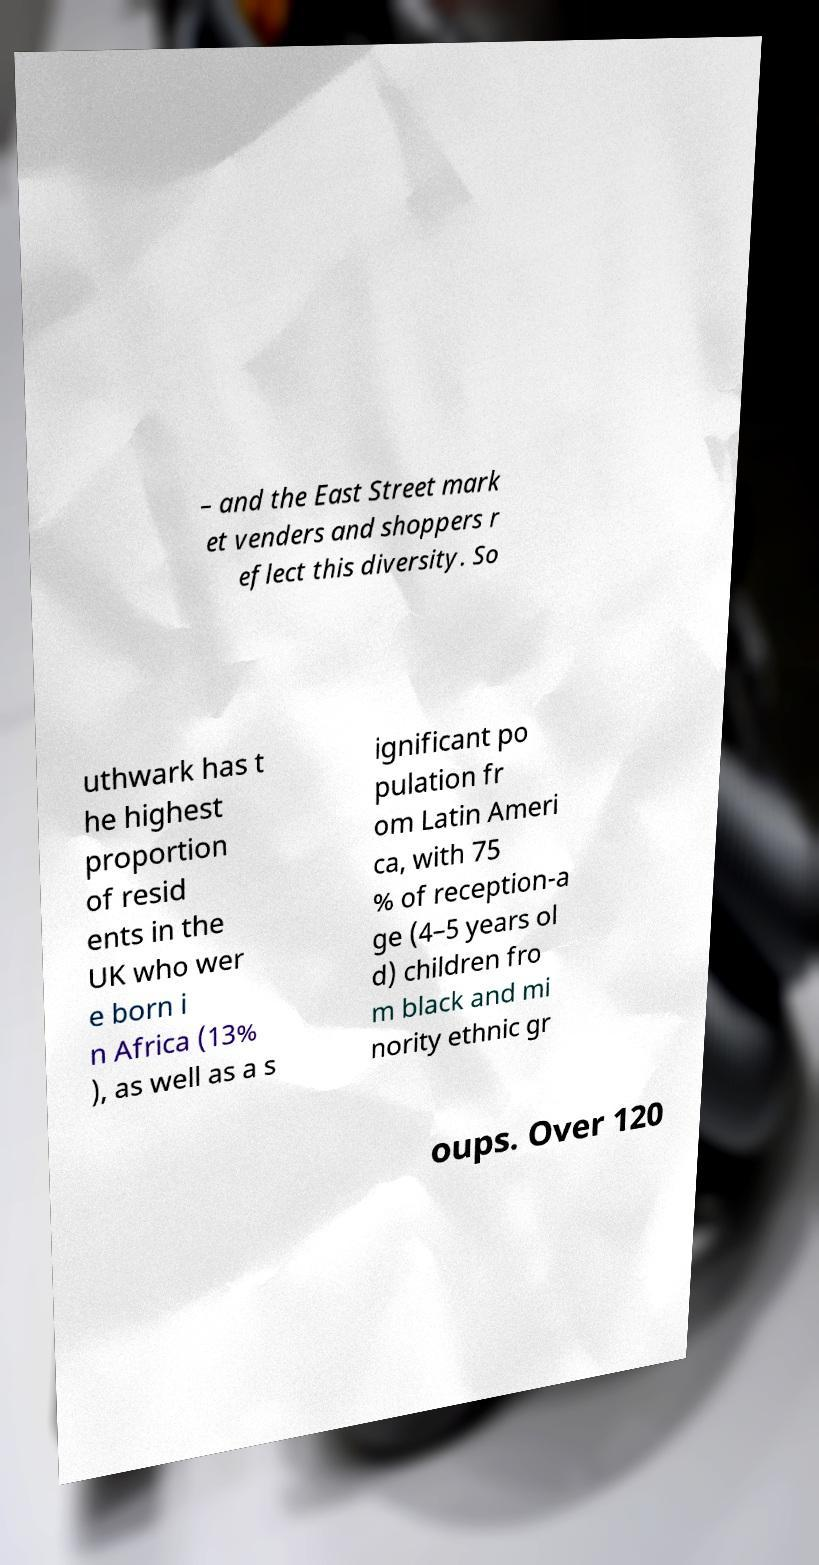Could you extract and type out the text from this image? – and the East Street mark et venders and shoppers r eflect this diversity. So uthwark has t he highest proportion of resid ents in the UK who wer e born i n Africa (13% ), as well as a s ignificant po pulation fr om Latin Ameri ca, with 75 % of reception-a ge (4–5 years ol d) children fro m black and mi nority ethnic gr oups. Over 120 